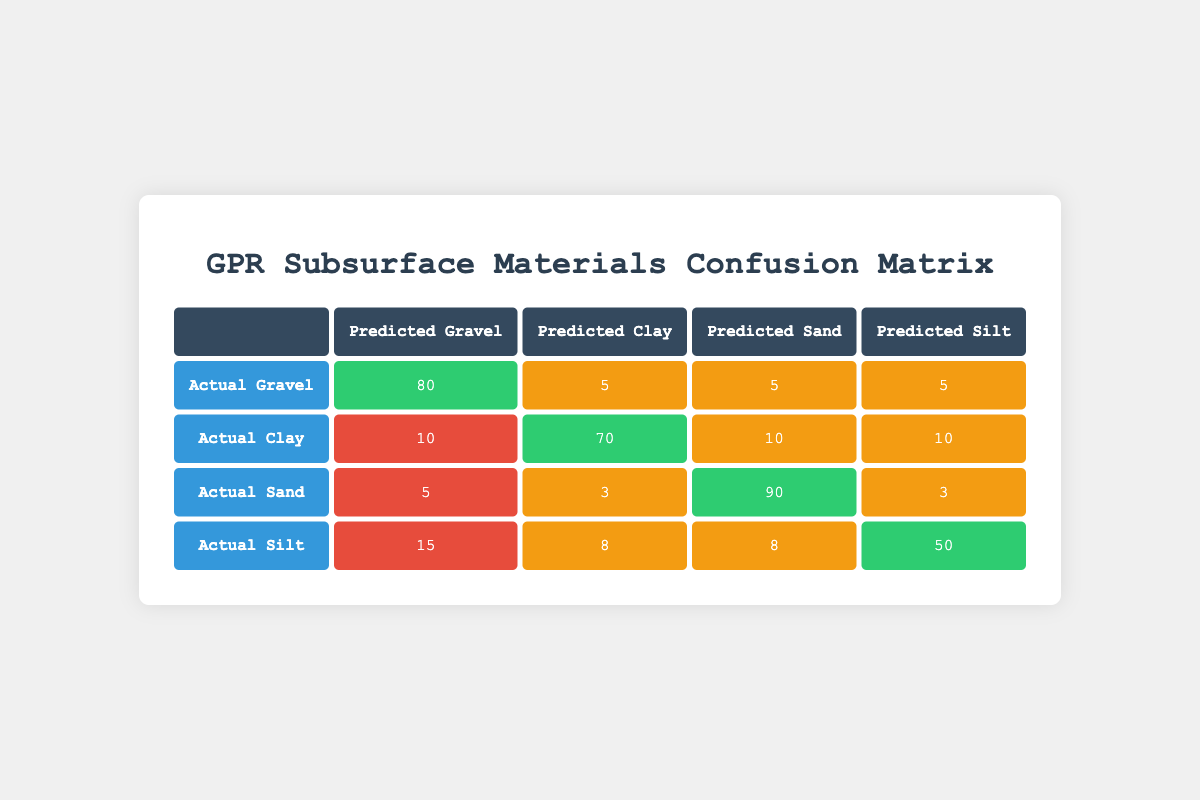What is the True Positive count for Gravel? The True Positive count for Gravel is directly available in the table under the Actual Gravel row and Predicted Gravel column, which shows the value of 80.
Answer: 80 How many False Positives were predicted for Clay? The False Positives for Clay are found in the Actual Clay row and Predicted Gravel column of the table, which is 10.
Answer: 10 What is the total number of actual Sand samples (True Positive + False Negative)? To find the total number of actual Sand samples, we add the True Positive (90) and False Negative (3) values for Sand: 90 + 3 = 93.
Answer: 93 Is the True Positive for Silt greater than the True Positive for Clay? The True Positive for Silt is 50, and for Clay, it is 70. Since 50 is not greater than 70, the answer is no.
Answer: No What is the overall False Negative rate across all materials? To find the overall False Negative rate, sum the False Negative counts for all materials: Gravel (5) + Clay (10) + Sand (3) + Silt (8) = 26. The True Positive counts give us the totals: Gravel (80) + Clay (70) + Sand (90) + Silt (50) = 290. The False Negative rate is 26/290, which is approximately 0.0897 or 8.97%.
Answer: 8.97% How many actual Gravel samples were classified incorrectly? The incorrect classifications of actual Gravel samples are represented by False Negatives, which is 5. This is indicated in the table within the Actual Gravel row and the False Negative column.
Answer: 5 What is the total number of False Positives for all materials combined? To calculate the total number of False Positives, sum the False Positives for each material: Gravel (10) + Clay (20) + Sand (5) + Silt (15) = 50.
Answer: 50 Which material has the highest True Positive count? By examining the True Positive counts, Gravel has 80, Clay has 70, Sand has 90, and Silt has 50. Sand has the highest value at 90.
Answer: Sand 